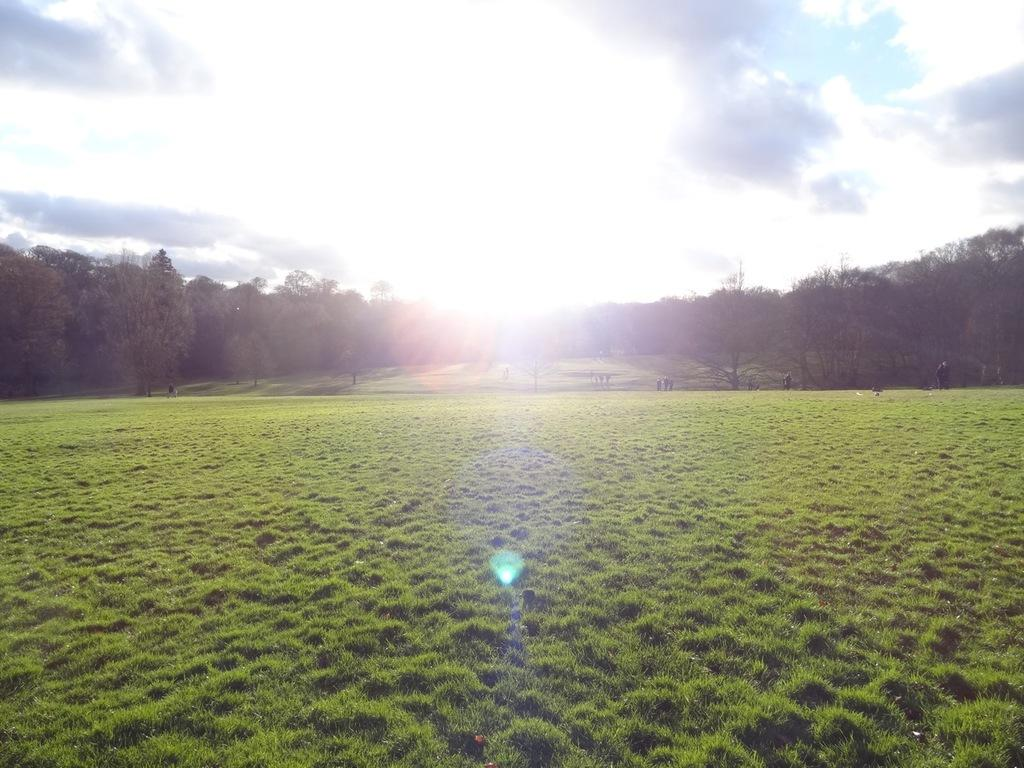What type of terrain is visible in the front of the image? There is a grassland in the front of the image. What structures can be seen in the back of the image? There are buildings in the back of the image. How are the buildings distributed across the land? The buildings are spread across the land. What is visible in the sky in the image? The sky is visible in the image, with clouds and the sun present. What type of ink is used to draw the clouds in the image? There is no ink present in the image, as it is a photograph or digital representation of the scene. How does the word "grassland" relate to the digestion process in the image? The term "grassland" refers to a type of terrain and does not have any direct connection to the digestion process. 